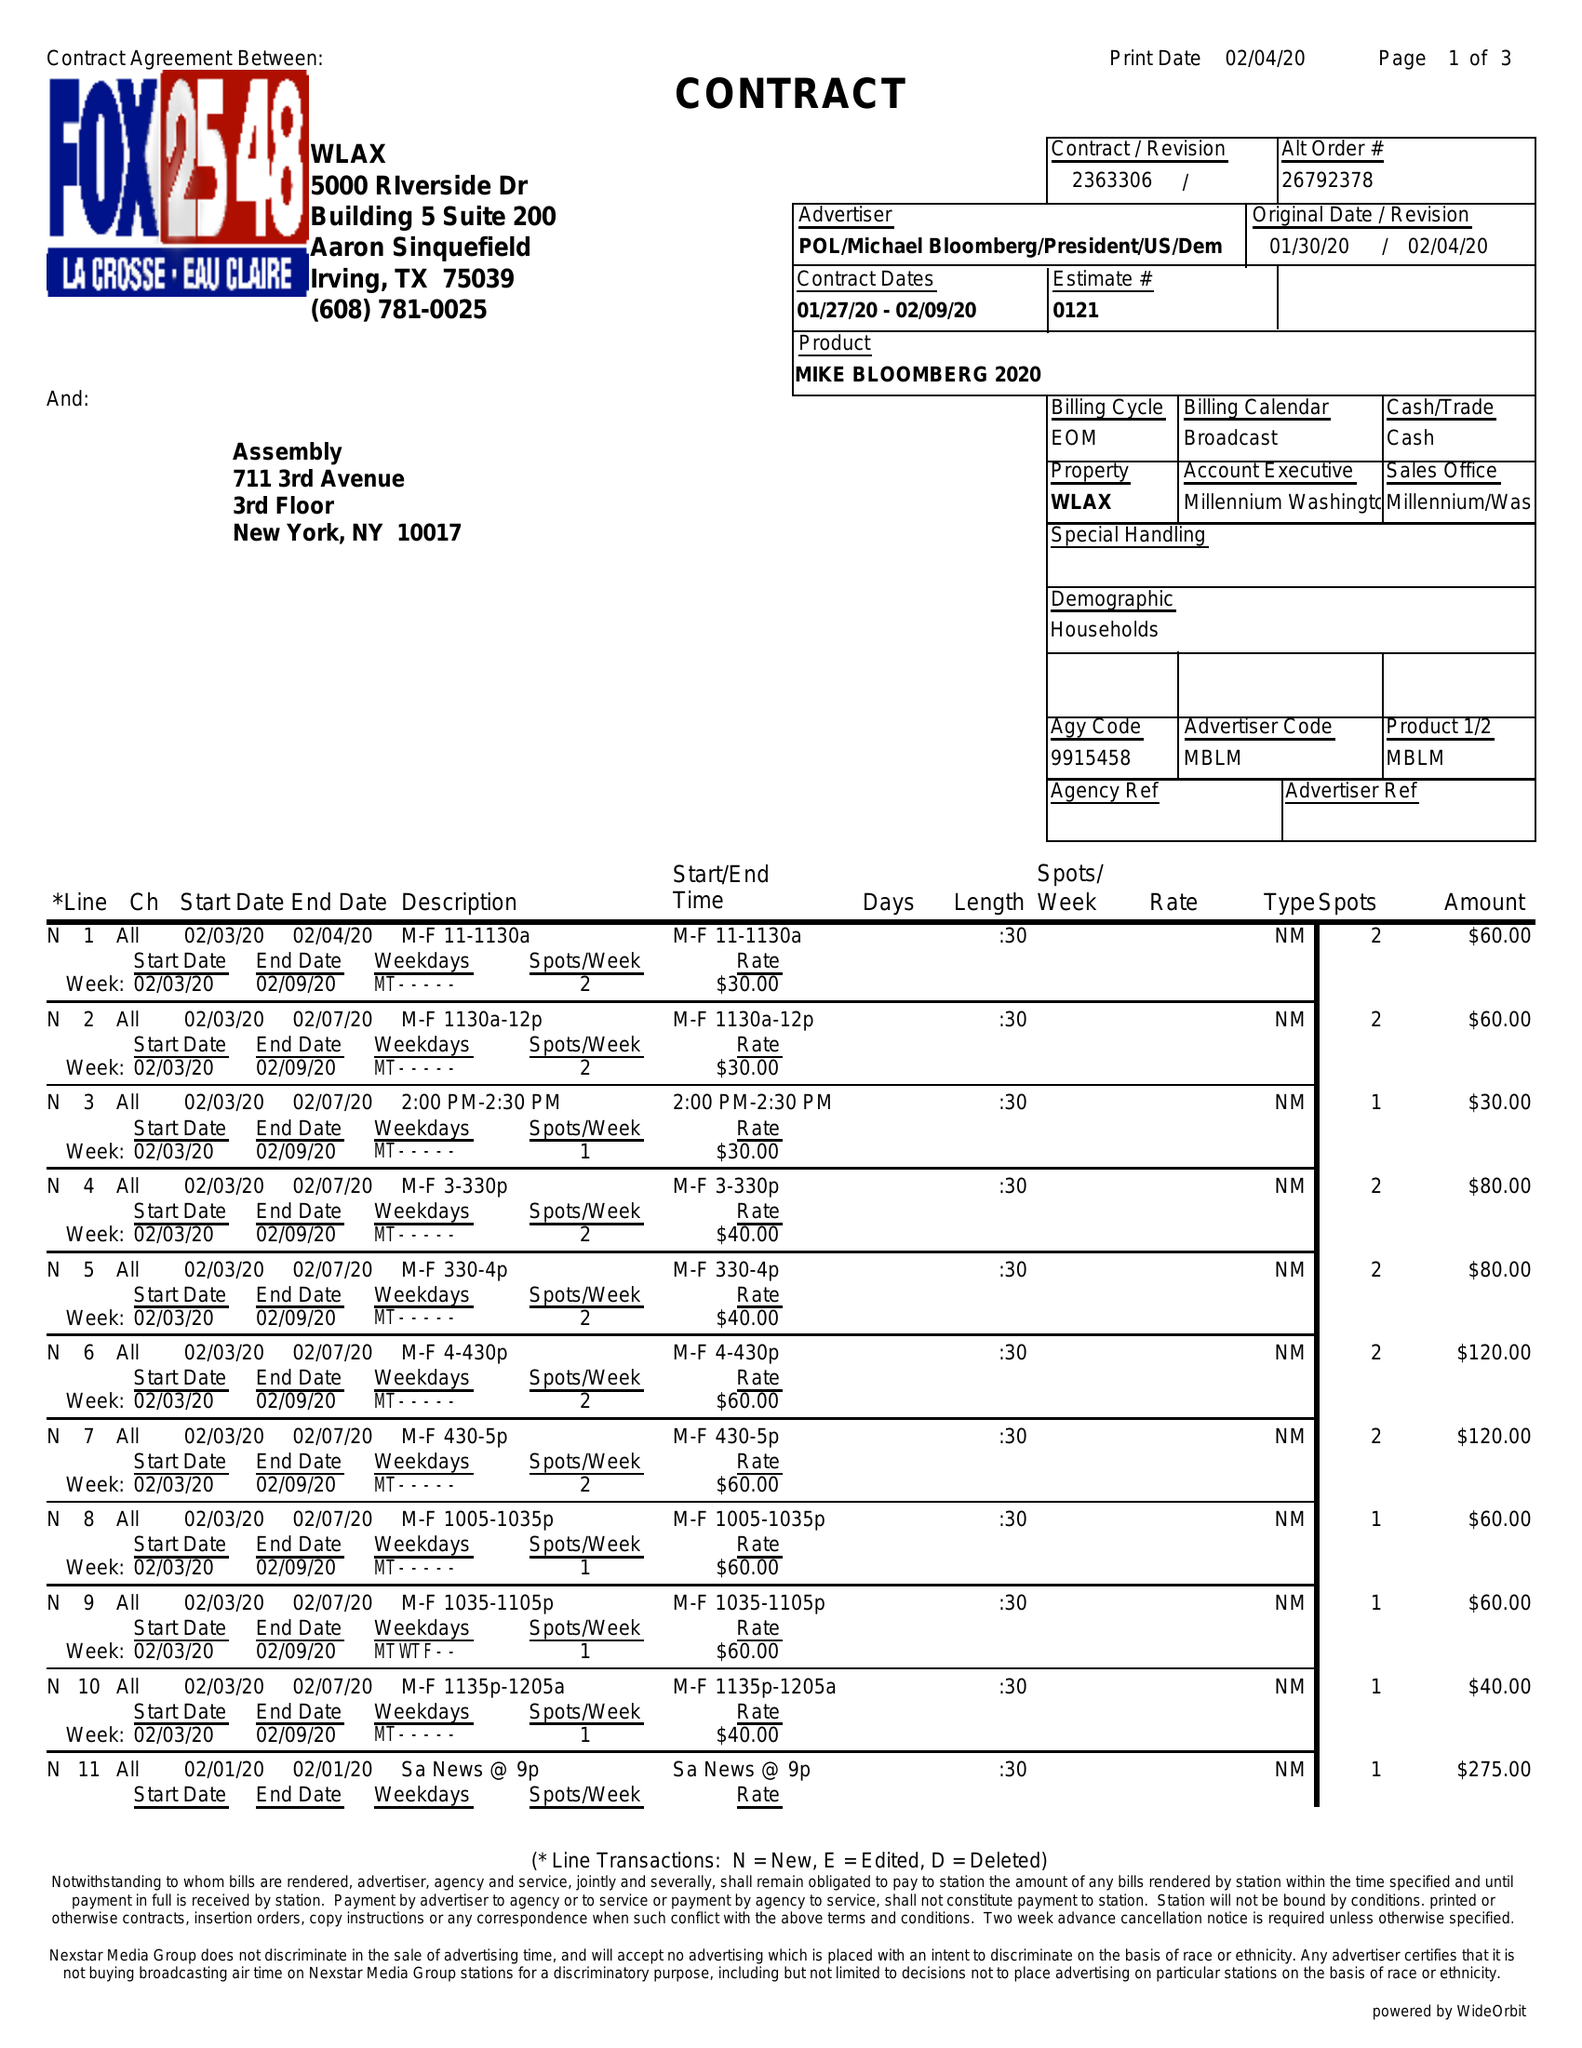What is the value for the flight_to?
Answer the question using a single word or phrase. 02/09/20 